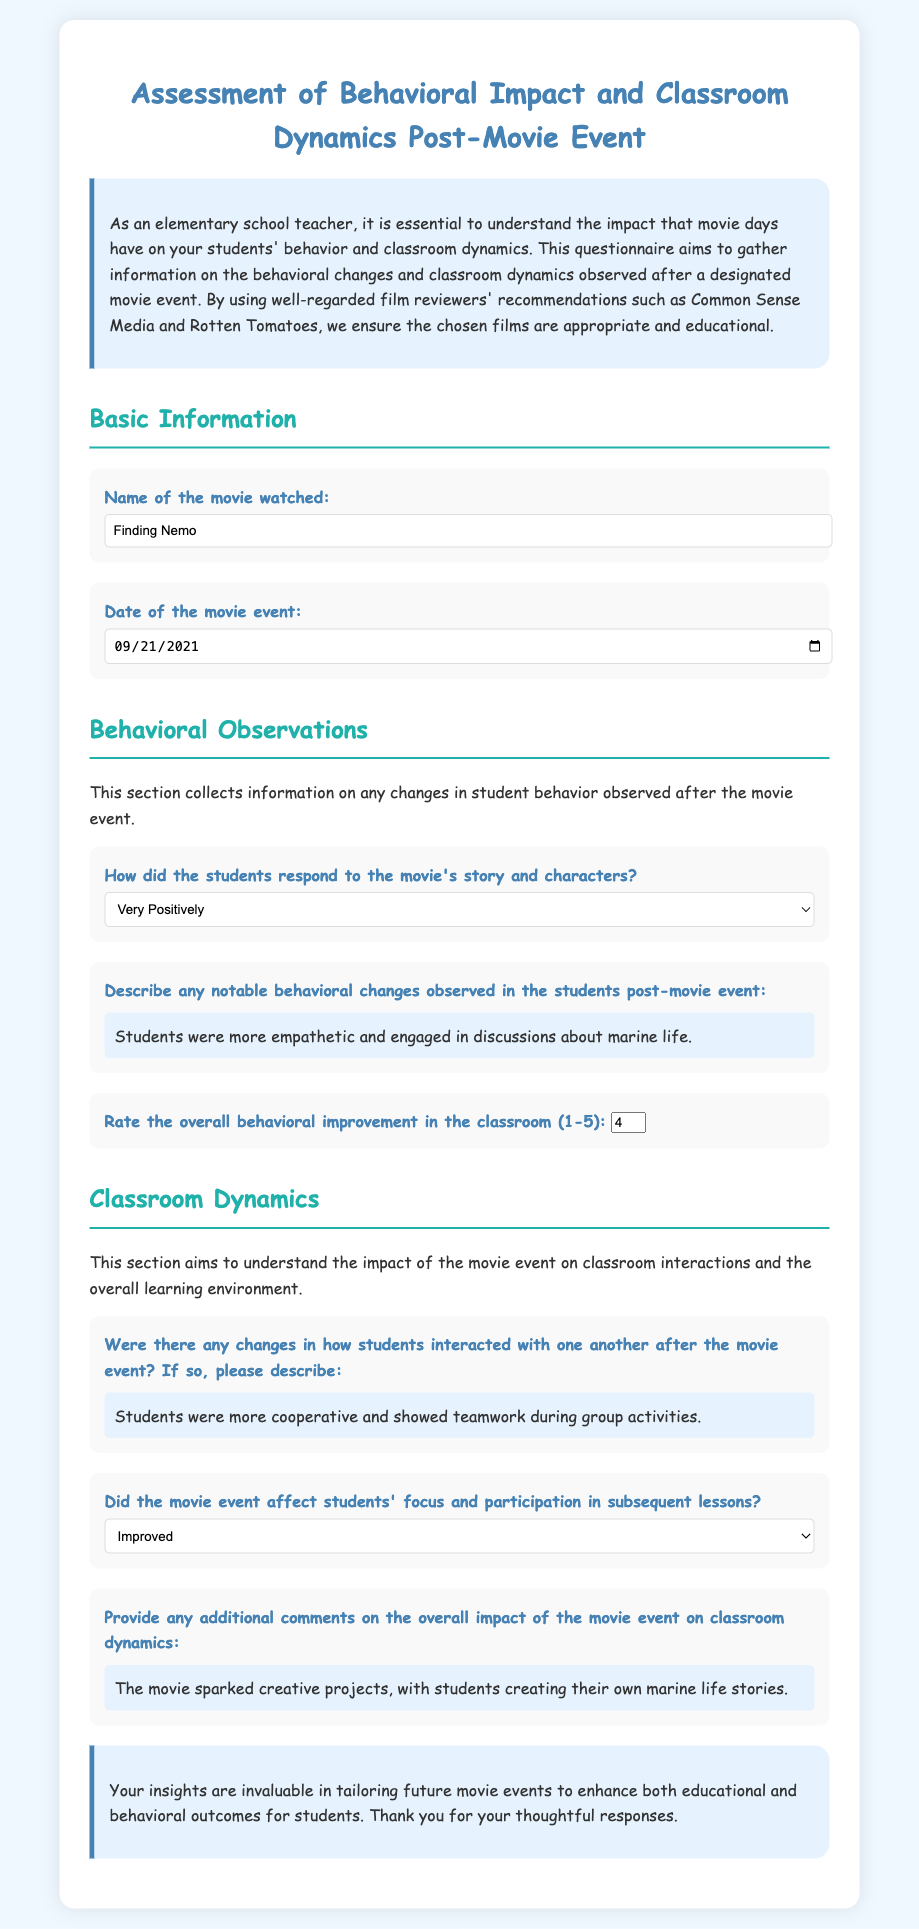What is the name of the movie watched? The name of the movie is specified in the questionnaire under "Name of the movie watched."
Answer: Finding Nemo What is the date of the movie event? The date of the movie event is given under "Date of the movie event."
Answer: 2021-09-21 How did the students respond to the movie's story and characters? The response category can be found in the section titled "Behavioral Observations."
Answer: Very Positively What notable behavioral change was observed in the students? The answer is provided under "Describe any notable behavioral changes observed in the students post-movie event."
Answer: Students were more empathetic and engaged in discussions about marine life What rating was given for overall behavioral improvement in the classroom? The rating is asked in the "Rate the overall behavioral improvement in the classroom" question and is a number.
Answer: 4 Did the movie event affect students' focus and participation in subsequent lessons? The impact on focus and participation is indicated in the selection under "Did the movie event affect students' focus and participation in subsequent lessons?"
Answer: Improved What changes in student interaction were noted after the movie? This change is detailed in the question regarding changes in how students interacted with one another after the movie event.
Answer: Students were more cooperative and showed teamwork during group activities What additional comment was provided about the overall impact of the movie event? The comments are shared in the "Provide any additional comments" section of the document.
Answer: The movie sparked creative projects, with students creating their own marine life stories 